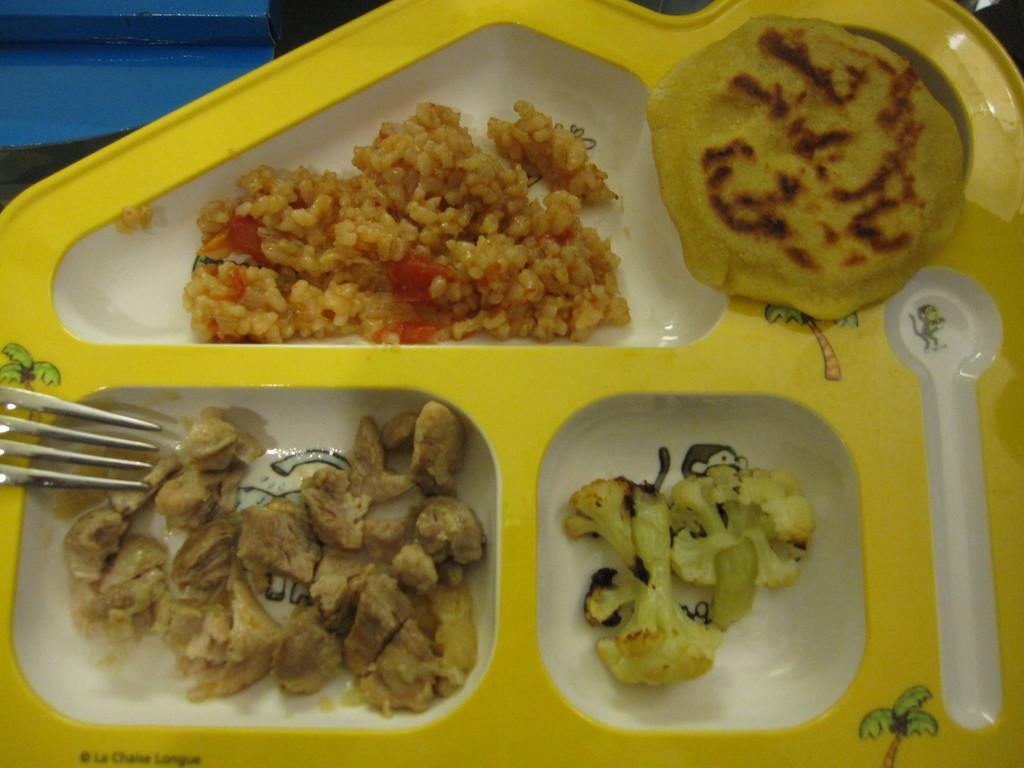Could you give a brief overview of what you see in this image? In this picture we can see some food in a plate. There is a fork. 